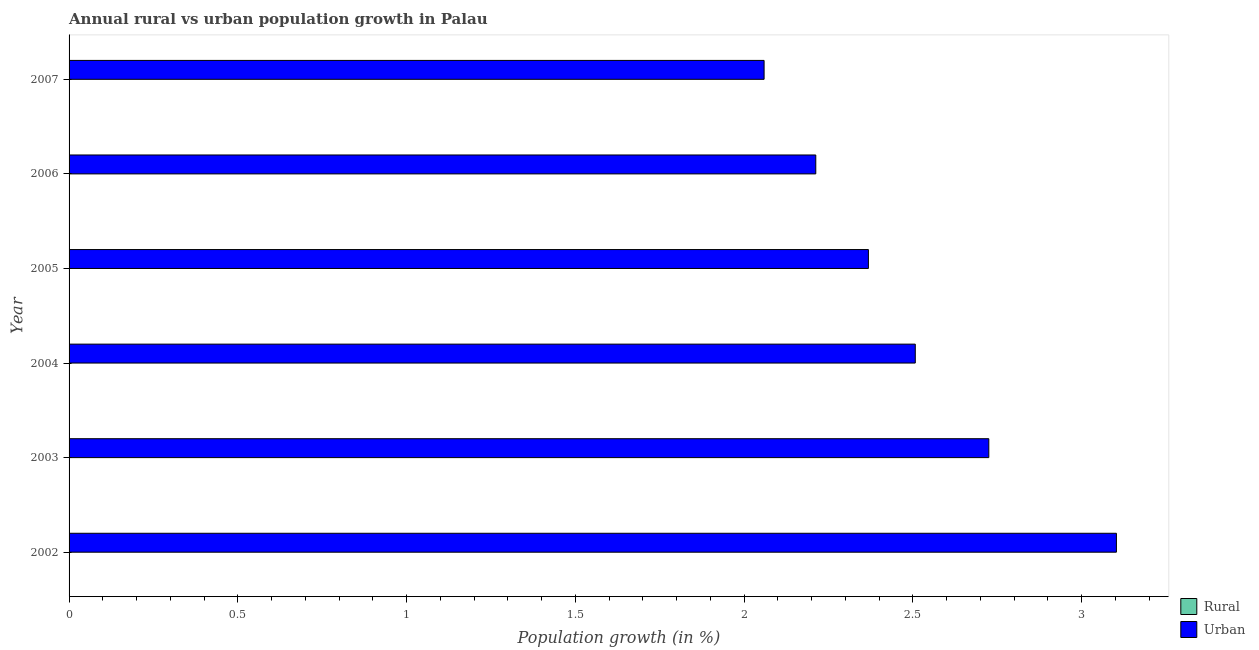In how many cases, is the number of bars for a given year not equal to the number of legend labels?
Offer a terse response. 6. What is the urban population growth in 2006?
Offer a very short reply. 2.21. Across all years, what is the maximum urban population growth?
Provide a short and direct response. 3.1. Across all years, what is the minimum urban population growth?
Keep it short and to the point. 2.06. What is the difference between the urban population growth in 2002 and that in 2007?
Ensure brevity in your answer.  1.04. What is the difference between the urban population growth in 2006 and the rural population growth in 2004?
Your answer should be compact. 2.21. What is the average rural population growth per year?
Provide a succinct answer. 0. What is the ratio of the urban population growth in 2003 to that in 2006?
Provide a short and direct response. 1.23. Is the urban population growth in 2002 less than that in 2006?
Keep it short and to the point. No. What is the difference between the highest and the second highest urban population growth?
Provide a succinct answer. 0.38. What is the difference between the highest and the lowest urban population growth?
Your answer should be very brief. 1.04. Is the sum of the urban population growth in 2005 and 2006 greater than the maximum rural population growth across all years?
Your answer should be compact. Yes. How many bars are there?
Offer a terse response. 6. What is the difference between two consecutive major ticks on the X-axis?
Make the answer very short. 0.5. Does the graph contain any zero values?
Give a very brief answer. Yes. How are the legend labels stacked?
Give a very brief answer. Vertical. What is the title of the graph?
Ensure brevity in your answer.  Annual rural vs urban population growth in Palau. What is the label or title of the X-axis?
Make the answer very short. Population growth (in %). What is the Population growth (in %) in Urban  in 2002?
Your response must be concise. 3.1. What is the Population growth (in %) of Urban  in 2003?
Your answer should be compact. 2.72. What is the Population growth (in %) of Rural in 2004?
Make the answer very short. 0. What is the Population growth (in %) in Urban  in 2004?
Ensure brevity in your answer.  2.51. What is the Population growth (in %) of Rural in 2005?
Your answer should be compact. 0. What is the Population growth (in %) in Urban  in 2005?
Keep it short and to the point. 2.37. What is the Population growth (in %) in Urban  in 2006?
Keep it short and to the point. 2.21. What is the Population growth (in %) in Rural in 2007?
Your answer should be very brief. 0. What is the Population growth (in %) in Urban  in 2007?
Give a very brief answer. 2.06. Across all years, what is the maximum Population growth (in %) of Urban ?
Provide a succinct answer. 3.1. Across all years, what is the minimum Population growth (in %) in Urban ?
Offer a very short reply. 2.06. What is the total Population growth (in %) of Rural in the graph?
Offer a very short reply. 0. What is the total Population growth (in %) in Urban  in the graph?
Provide a short and direct response. 14.97. What is the difference between the Population growth (in %) in Urban  in 2002 and that in 2003?
Your answer should be very brief. 0.38. What is the difference between the Population growth (in %) of Urban  in 2002 and that in 2004?
Make the answer very short. 0.6. What is the difference between the Population growth (in %) of Urban  in 2002 and that in 2005?
Your answer should be very brief. 0.73. What is the difference between the Population growth (in %) of Urban  in 2002 and that in 2006?
Your answer should be very brief. 0.89. What is the difference between the Population growth (in %) of Urban  in 2002 and that in 2007?
Offer a terse response. 1.04. What is the difference between the Population growth (in %) in Urban  in 2003 and that in 2004?
Ensure brevity in your answer.  0.22. What is the difference between the Population growth (in %) of Urban  in 2003 and that in 2005?
Your answer should be very brief. 0.36. What is the difference between the Population growth (in %) of Urban  in 2003 and that in 2006?
Offer a terse response. 0.51. What is the difference between the Population growth (in %) in Urban  in 2003 and that in 2007?
Provide a short and direct response. 0.67. What is the difference between the Population growth (in %) of Urban  in 2004 and that in 2005?
Your answer should be compact. 0.14. What is the difference between the Population growth (in %) of Urban  in 2004 and that in 2006?
Your answer should be very brief. 0.29. What is the difference between the Population growth (in %) in Urban  in 2004 and that in 2007?
Keep it short and to the point. 0.45. What is the difference between the Population growth (in %) of Urban  in 2005 and that in 2006?
Give a very brief answer. 0.16. What is the difference between the Population growth (in %) of Urban  in 2005 and that in 2007?
Offer a very short reply. 0.31. What is the difference between the Population growth (in %) in Urban  in 2006 and that in 2007?
Offer a terse response. 0.15. What is the average Population growth (in %) in Urban  per year?
Keep it short and to the point. 2.5. What is the ratio of the Population growth (in %) in Urban  in 2002 to that in 2003?
Your answer should be compact. 1.14. What is the ratio of the Population growth (in %) in Urban  in 2002 to that in 2004?
Provide a succinct answer. 1.24. What is the ratio of the Population growth (in %) of Urban  in 2002 to that in 2005?
Make the answer very short. 1.31. What is the ratio of the Population growth (in %) in Urban  in 2002 to that in 2006?
Provide a succinct answer. 1.4. What is the ratio of the Population growth (in %) in Urban  in 2002 to that in 2007?
Keep it short and to the point. 1.51. What is the ratio of the Population growth (in %) of Urban  in 2003 to that in 2004?
Provide a succinct answer. 1.09. What is the ratio of the Population growth (in %) of Urban  in 2003 to that in 2005?
Provide a short and direct response. 1.15. What is the ratio of the Population growth (in %) of Urban  in 2003 to that in 2006?
Provide a short and direct response. 1.23. What is the ratio of the Population growth (in %) of Urban  in 2003 to that in 2007?
Provide a succinct answer. 1.32. What is the ratio of the Population growth (in %) of Urban  in 2004 to that in 2005?
Provide a succinct answer. 1.06. What is the ratio of the Population growth (in %) in Urban  in 2004 to that in 2006?
Your response must be concise. 1.13. What is the ratio of the Population growth (in %) in Urban  in 2004 to that in 2007?
Give a very brief answer. 1.22. What is the ratio of the Population growth (in %) of Urban  in 2005 to that in 2006?
Make the answer very short. 1.07. What is the ratio of the Population growth (in %) of Urban  in 2005 to that in 2007?
Your response must be concise. 1.15. What is the ratio of the Population growth (in %) of Urban  in 2006 to that in 2007?
Give a very brief answer. 1.07. What is the difference between the highest and the second highest Population growth (in %) of Urban ?
Provide a short and direct response. 0.38. What is the difference between the highest and the lowest Population growth (in %) in Urban ?
Your response must be concise. 1.04. 